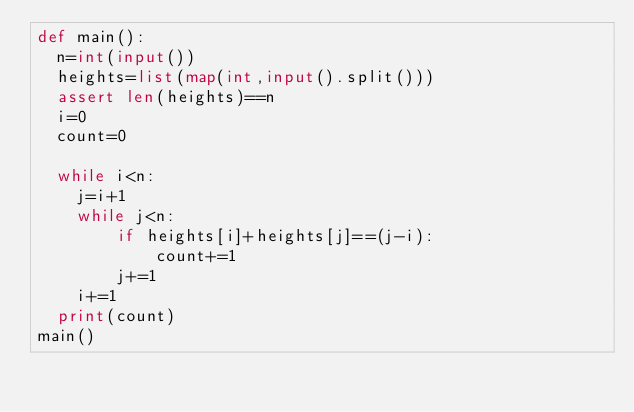Convert code to text. <code><loc_0><loc_0><loc_500><loc_500><_Python_>def main():
  n=int(input())
  heights=list(map(int,input().split()))
  assert len(heights)==n
  i=0
  count=0

  while i<n:
    j=i+1
    while j<n:
        if heights[i]+heights[j]==(j-i):
            count+=1
        j+=1
    i+=1
  print(count)
main()</code> 